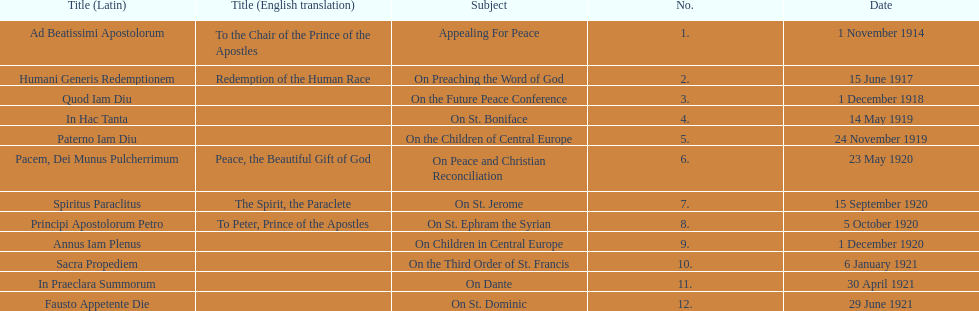What was the number of encyclopedias that had subjects relating specifically to children? 2. 